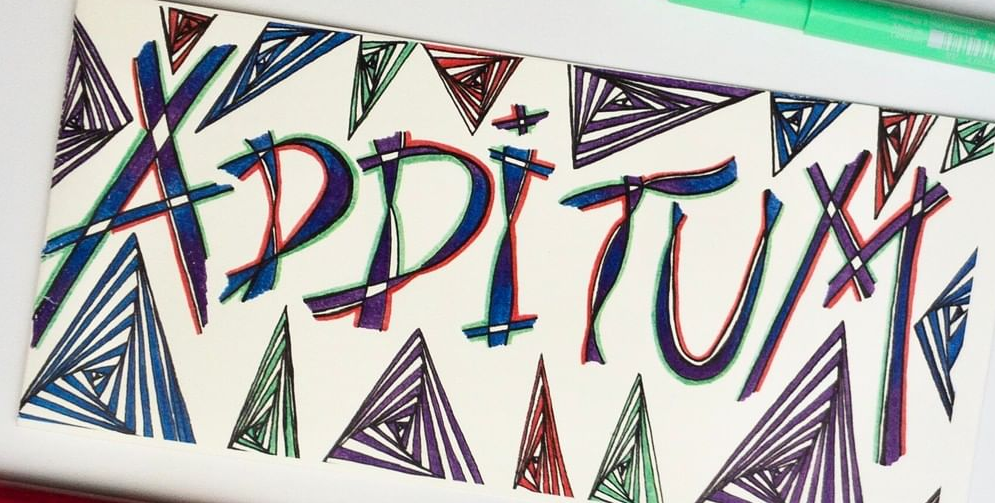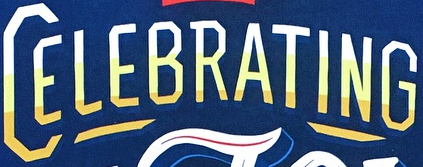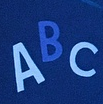Transcribe the words shown in these images in order, separated by a semicolon. ADDITUM; CELEBRATING; ABC 